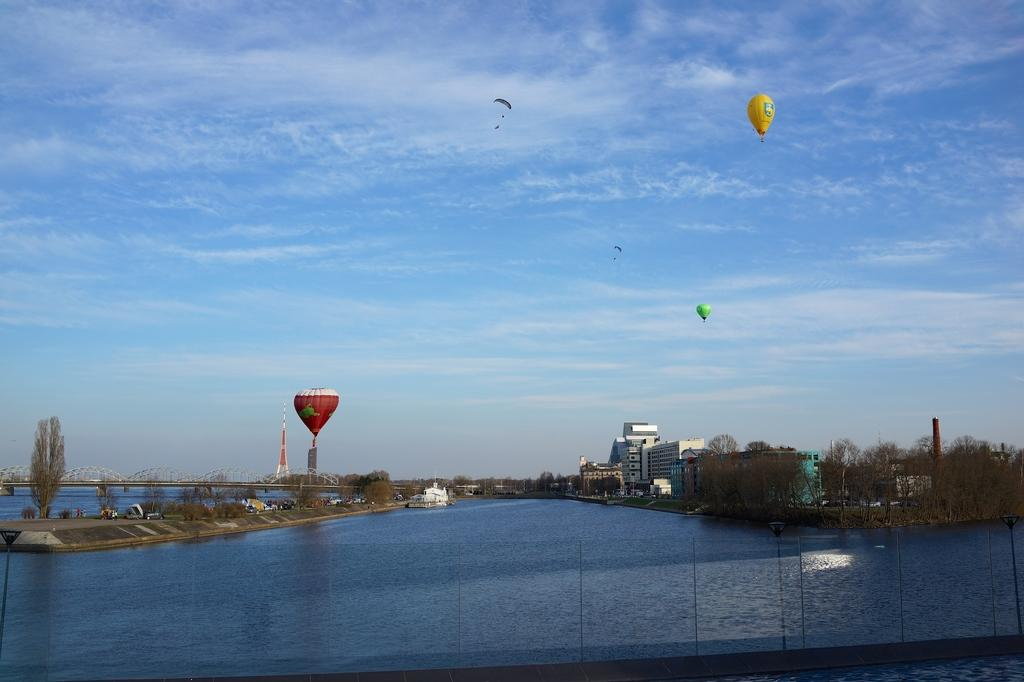What type of natural body of water is present in the image? There is a sea in the image. What are the airborne objects visible in the sky? Air balloons are flying in the sky. What type of vegetation can be seen in the image? There are trees visible in the image. What type of man-made structures are present in the image? There are buildings in the image. What type of transportation infrastructure is present in the image? There is a bridge in the image. What is the condition of the sky in the image? The sky is clear in the image. What type of harmony is being played by the band in the image? There is no band present in the image, so it is not possible to determine what type of harmony might be played. 